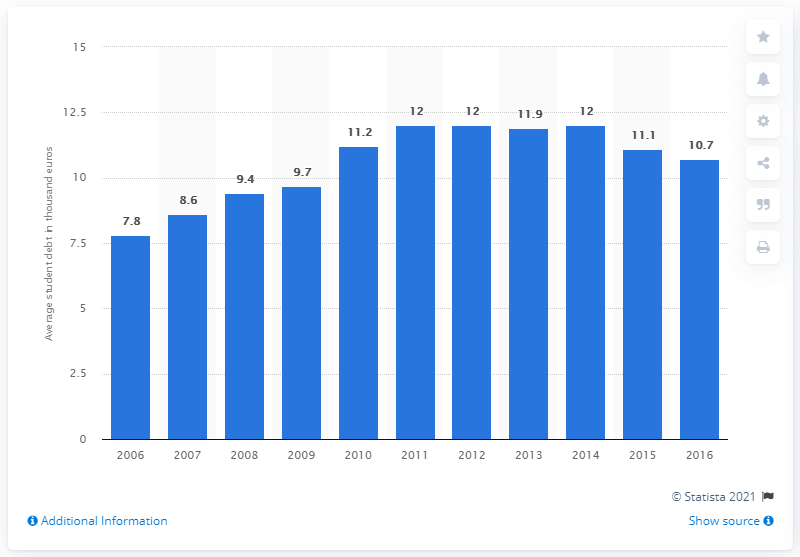Point out several critical features in this image. The national system for student loans underwent a significant change in 2015. 